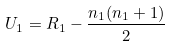Convert formula to latex. <formula><loc_0><loc_0><loc_500><loc_500>U _ { 1 } = R _ { 1 } - { \frac { n _ { 1 } ( n _ { 1 } + 1 ) } { 2 } } \,</formula> 